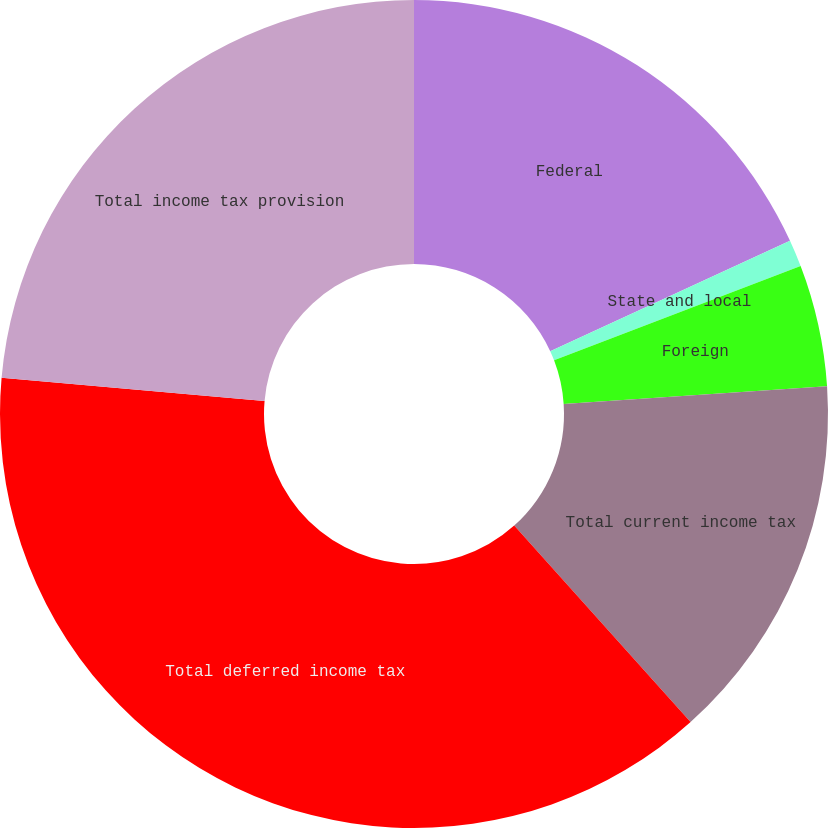Convert chart to OTSL. <chart><loc_0><loc_0><loc_500><loc_500><pie_chart><fcel>Federal<fcel>State and local<fcel>Foreign<fcel>Total current income tax<fcel>Total deferred income tax<fcel>Total income tax provision<nl><fcel>18.13%<fcel>1.05%<fcel>4.75%<fcel>14.43%<fcel>38.04%<fcel>23.61%<nl></chart> 